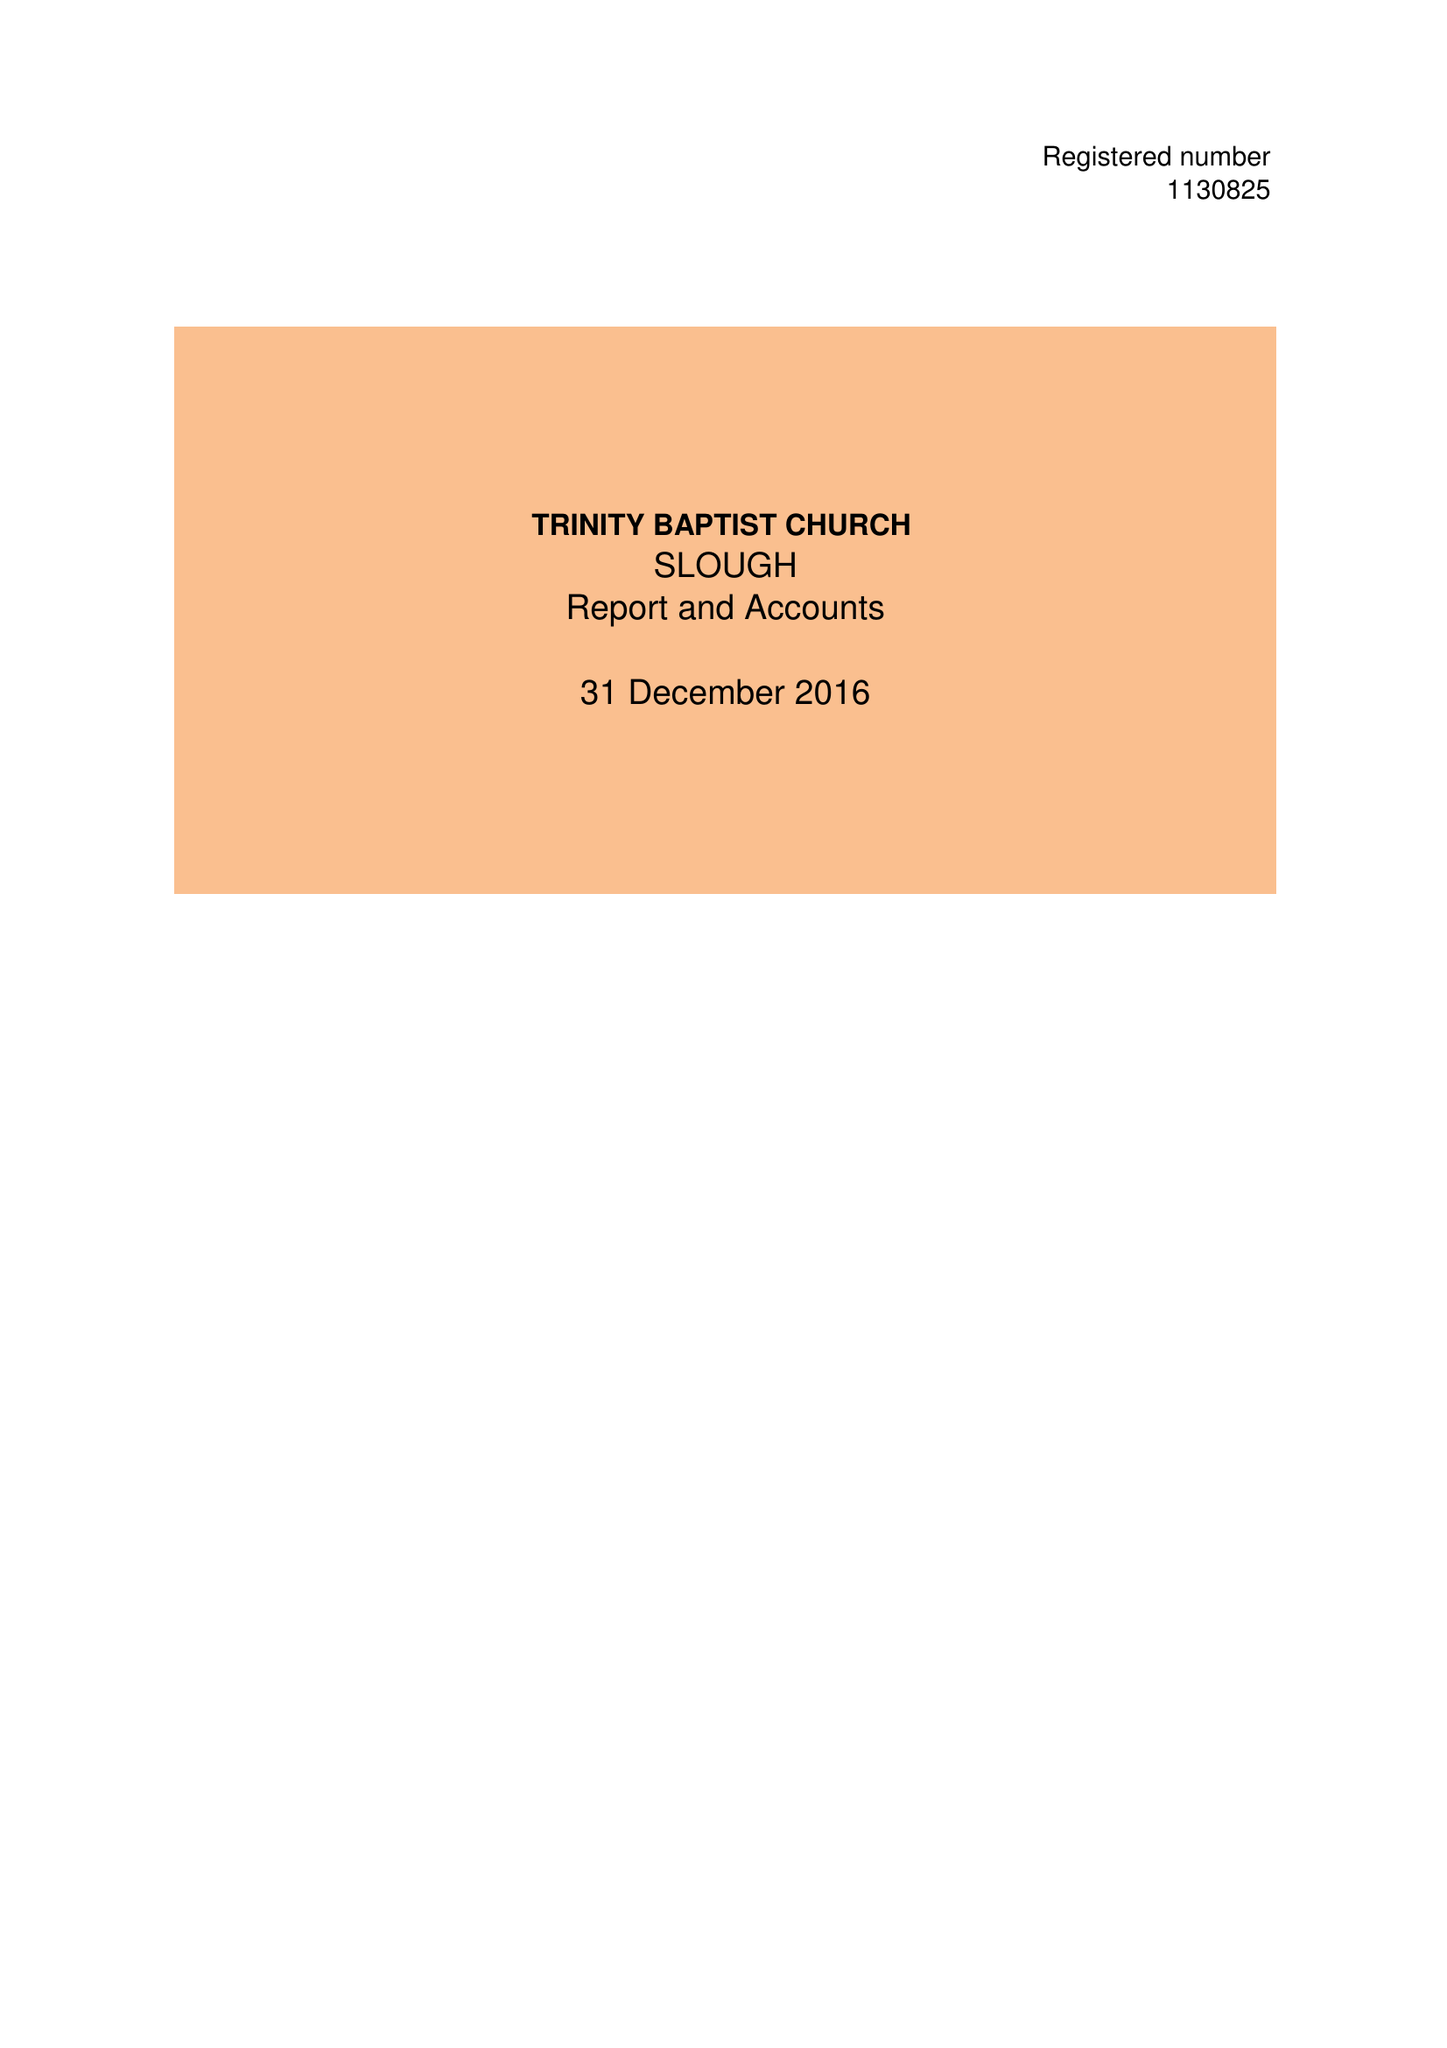What is the value for the address__post_town?
Answer the question using a single word or phrase. CROYDON 